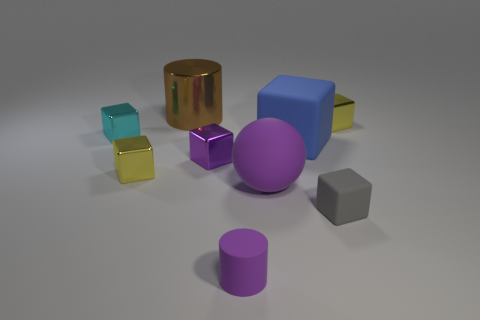Subtract 2 cubes. How many cubes are left? 4 Subtract all cyan blocks. How many blocks are left? 5 Subtract all tiny cyan blocks. How many blocks are left? 5 Subtract all blue blocks. Subtract all blue balls. How many blocks are left? 5 Subtract all cylinders. How many objects are left? 7 Subtract all metallic cylinders. Subtract all red cubes. How many objects are left? 8 Add 8 yellow metallic cubes. How many yellow metallic cubes are left? 10 Add 5 gray blocks. How many gray blocks exist? 6 Subtract 1 purple cubes. How many objects are left? 8 